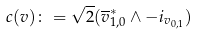<formula> <loc_0><loc_0><loc_500><loc_500>c ( v ) \colon = \sqrt { 2 } ( { \overline { v } ^ { \ast } _ { 1 , 0 } } \wedge - i _ { v _ { 0 , 1 } } )</formula> 